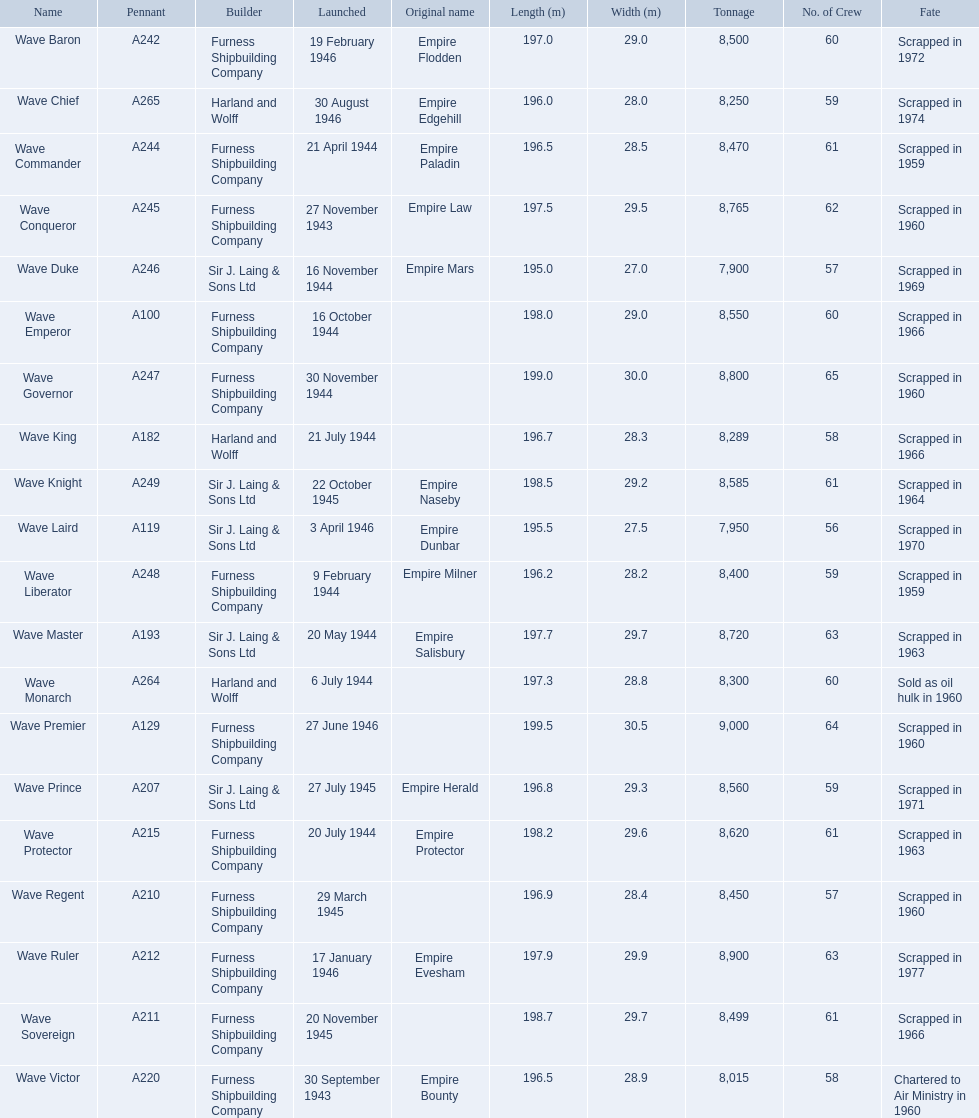Would you mind parsing the complete table? {'header': ['Name', 'Pennant', 'Builder', 'Launched', 'Original name', 'Length (m)', 'Width (m)', 'Tonnage', 'No. of Crew', 'Fate'], 'rows': [['Wave Baron', 'A242', 'Furness Shipbuilding Company', '19 February 1946', 'Empire Flodden', '197.0', '29.0', '8,500', '60', 'Scrapped in 1972'], ['Wave Chief', 'A265', 'Harland and Wolff', '30 August 1946', 'Empire Edgehill', '196.0', '28.0', '8,250', '59', 'Scrapped in 1974'], ['Wave Commander', 'A244', 'Furness Shipbuilding Company', '21 April 1944', 'Empire Paladin', '196.5', '28.5', '8,470', '61', 'Scrapped in 1959'], ['Wave Conqueror', 'A245', 'Furness Shipbuilding Company', '27 November 1943', 'Empire Law', '197.5', '29.5', '8,765', '62', 'Scrapped in 1960'], ['Wave Duke', 'A246', 'Sir J. Laing & Sons Ltd', '16 November 1944', 'Empire Mars', '195.0', '27.0', '7,900', '57', 'Scrapped in 1969'], ['Wave Emperor', 'A100', 'Furness Shipbuilding Company', '16 October 1944', '', '198.0', '29.0', '8,550', '60', 'Scrapped in 1966'], ['Wave Governor', 'A247', 'Furness Shipbuilding Company', '30 November 1944', '', '199.0', '30.0', '8,800', '65', 'Scrapped in 1960'], ['Wave King', 'A182', 'Harland and Wolff', '21 July 1944', '', '196.7', '28.3', '8,289', '58', 'Scrapped in 1966'], ['Wave Knight', 'A249', 'Sir J. Laing & Sons Ltd', '22 October 1945', 'Empire Naseby', '198.5', '29.2', '8,585', '61', 'Scrapped in 1964'], ['Wave Laird', 'A119', 'Sir J. Laing & Sons Ltd', '3 April 1946', 'Empire Dunbar', '195.5', '27.5', '7,950', '56', 'Scrapped in 1970'], ['Wave Liberator', 'A248', 'Furness Shipbuilding Company', '9 February 1944', 'Empire Milner', '196.2', '28.2', '8,400', '59', 'Scrapped in 1959'], ['Wave Master', 'A193', 'Sir J. Laing & Sons Ltd', '20 May 1944', 'Empire Salisbury', '197.7', '29.7', '8,720', '63', 'Scrapped in 1963'], ['Wave Monarch', 'A264', 'Harland and Wolff', '6 July 1944', '', '197.3', '28.8', '8,300', '60', 'Sold as oil hulk in 1960'], ['Wave Premier', 'A129', 'Furness Shipbuilding Company', '27 June 1946', '', '199.5', '30.5', '9,000', '64', 'Scrapped in 1960'], ['Wave Prince', 'A207', 'Sir J. Laing & Sons Ltd', '27 July 1945', 'Empire Herald', '196.8', '29.3', '8,560', '59', 'Scrapped in 1971'], ['Wave Protector', 'A215', 'Furness Shipbuilding Company', '20 July 1944', 'Empire Protector', '198.2', '29.6', '8,620', '61', 'Scrapped in 1963'], ['Wave Regent', 'A210', 'Furness Shipbuilding Company', '29 March 1945', '', '196.9', '28.4', '8,450', '57', 'Scrapped in 1960'], ['Wave Ruler', 'A212', 'Furness Shipbuilding Company', '17 January 1946', 'Empire Evesham', '197.9', '29.9', '8,900', '63', 'Scrapped in 1977'], ['Wave Sovereign', 'A211', 'Furness Shipbuilding Company', '20 November 1945', '', '198.7', '29.7', '8,499', '61', 'Scrapped in 1966'], ['Wave Victor', 'A220', 'Furness Shipbuilding Company', '30 September 1943', 'Empire Bounty', '196.5', '28.9', '8,015', '58', 'Chartered to Air Ministry in 1960']]} What year was the wave victor launched? 30 September 1943. What other ship was launched in 1943? Wave Conqueror. 